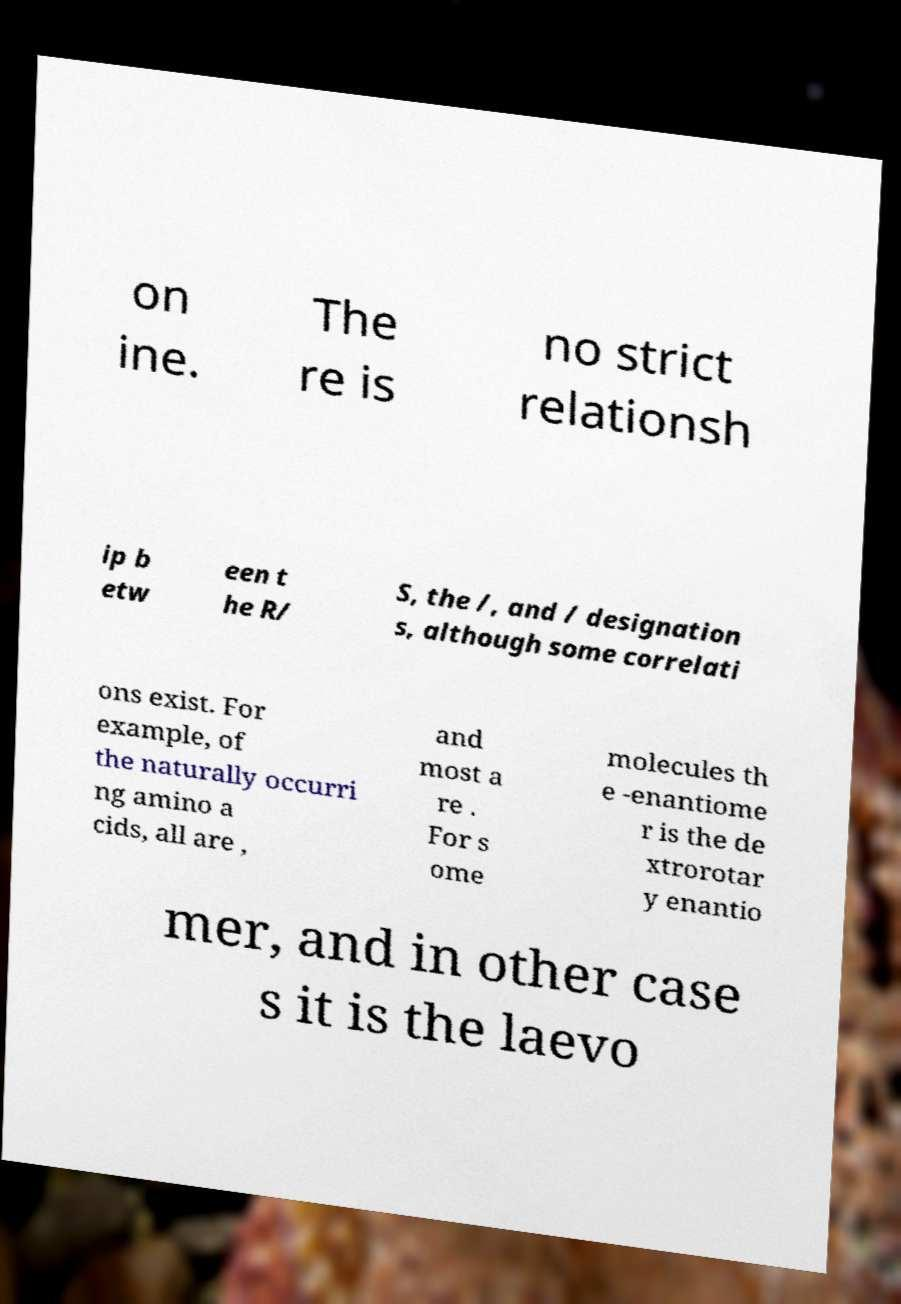What messages or text are displayed in this image? I need them in a readable, typed format. on ine. The re is no strict relationsh ip b etw een t he R/ S, the /, and / designation s, although some correlati ons exist. For example, of the naturally occurri ng amino a cids, all are , and most a re . For s ome molecules th e -enantiome r is the de xtrorotar y enantio mer, and in other case s it is the laevo 